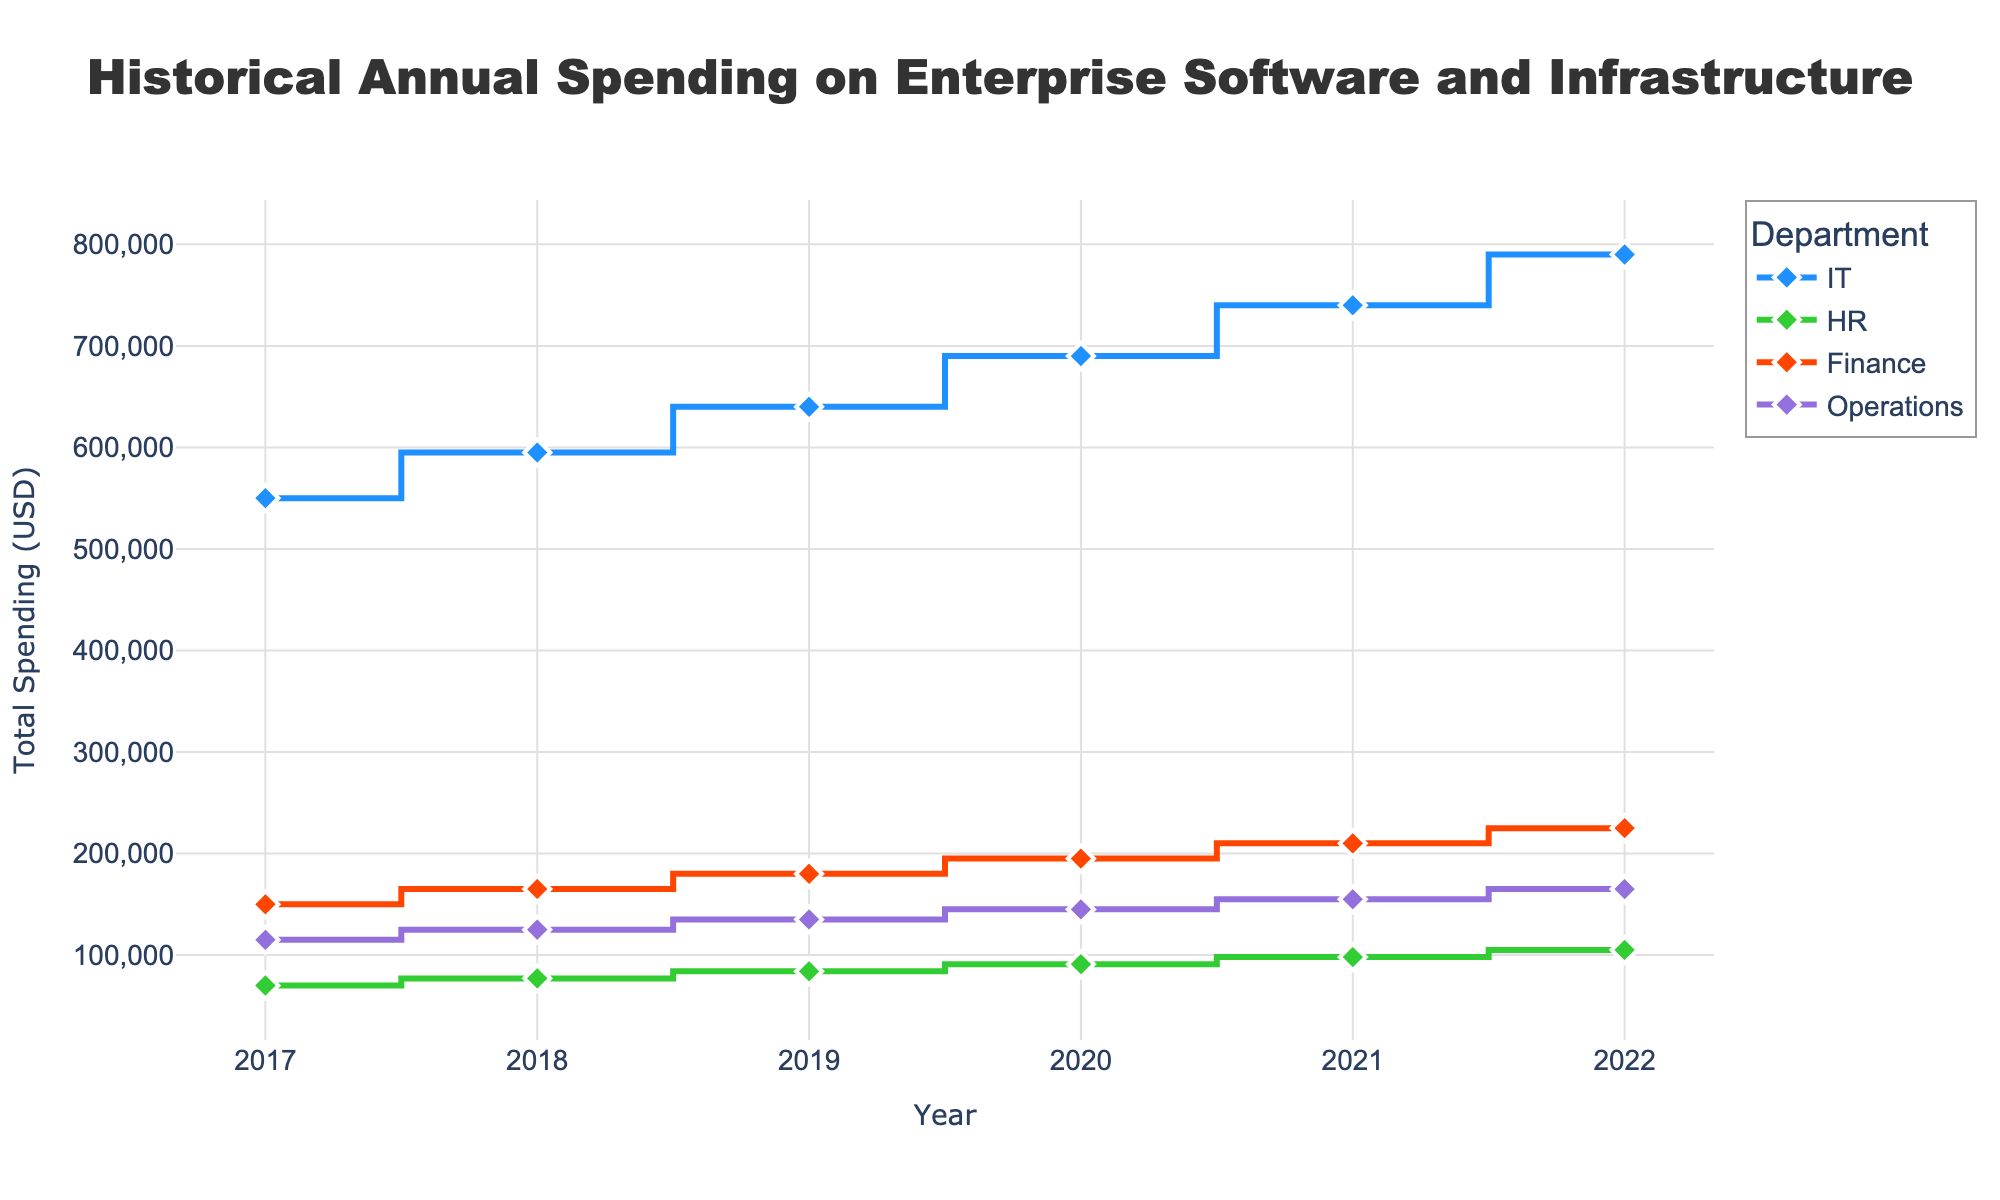What's the title of the figure? The title is usually displayed at the top center of the figure. In this case, it reads "Historical Annual Spending on Enterprise Software and Infrastructure".
Answer: Historical Annual Spending on Enterprise Software and Infrastructure Which department had the highest total spending in 2022? By examining the 2022 data points, the IT department shows the highest value on the y-axis.
Answer: IT What is the trend in spending for the IT department from 2017 to 2022? Observing the IT department's data points across the years, the line steadily increases, indicating a rising trend.
Answer: Rising How did the total spending for HR compare between 2017 and 2022? Looking at the data points for HR in 2017 and 2022, there's an increase from around 70,000 USD to 105,000 USD.
Answer: Increased In which year did the Finance department see the largest increase in spending from the previous year? Comparing yearly increments, the largest jump for the Finance department is between 2020 and 2021.
Answer: 2021 What was the combined spending on enterprise software and infrastructure for Operations in 2020? To find the combined spending, add the enterprise software and infrastructure expenditures for Operations in 2020 (90,000 + 55,000).
Answer: 145,000 Which department had the most stable spending over the years? By scanning the lines' variation (how much they rise and fall), the HR department displays the least fluctuation.
Answer: HR How much total spending did the IT department have over the five years from 2017 to 2022? Summing the yearly total spending for IT from 2017 to 2022: 550,000 + 595,000 + 640,000 + 690,000 + 740,000 = 3,215,000.
Answer: 3,215,000 Between 2018 and 2019, which department saw a greater increase in total spending, Finance or Operations? The increase for Finance is 60,000 and for Operations is 10,000. Finance saw a greater increase.
Answer: Finance For which department is the gap between enterprise software spending and infrastructure spending consistently the largest? Comparing the gaps of spending categories, the IT department has the consistently largest differences.
Answer: IT 